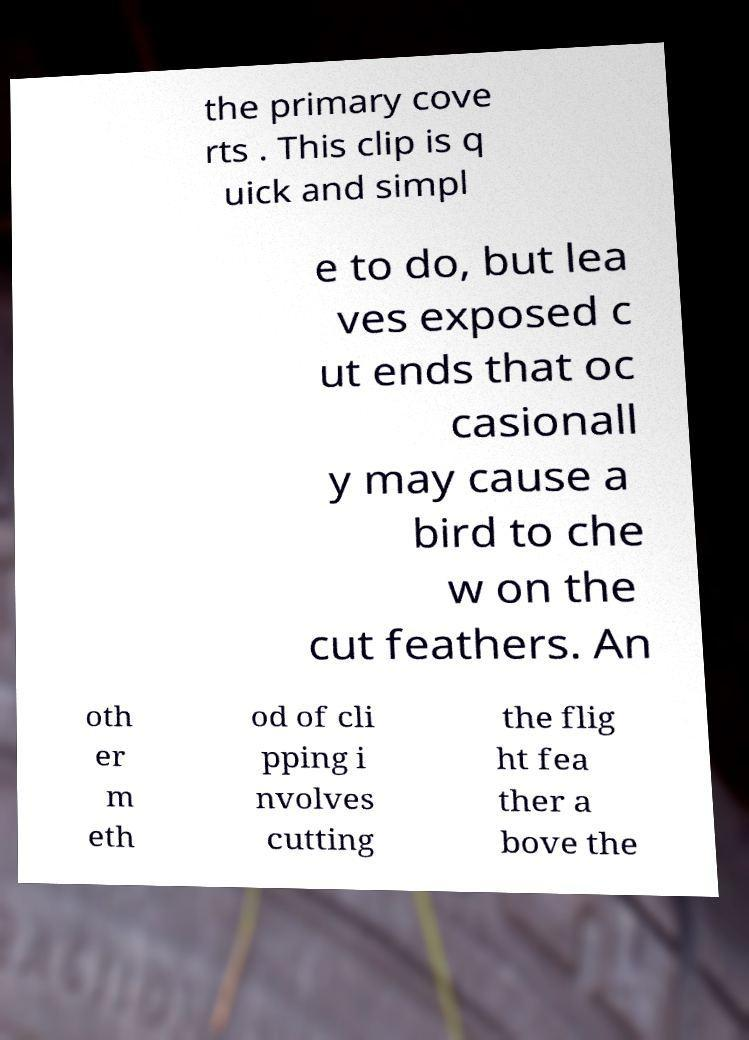There's text embedded in this image that I need extracted. Can you transcribe it verbatim? the primary cove rts . This clip is q uick and simpl e to do, but lea ves exposed c ut ends that oc casionall y may cause a bird to che w on the cut feathers. An oth er m eth od of cli pping i nvolves cutting the flig ht fea ther a bove the 